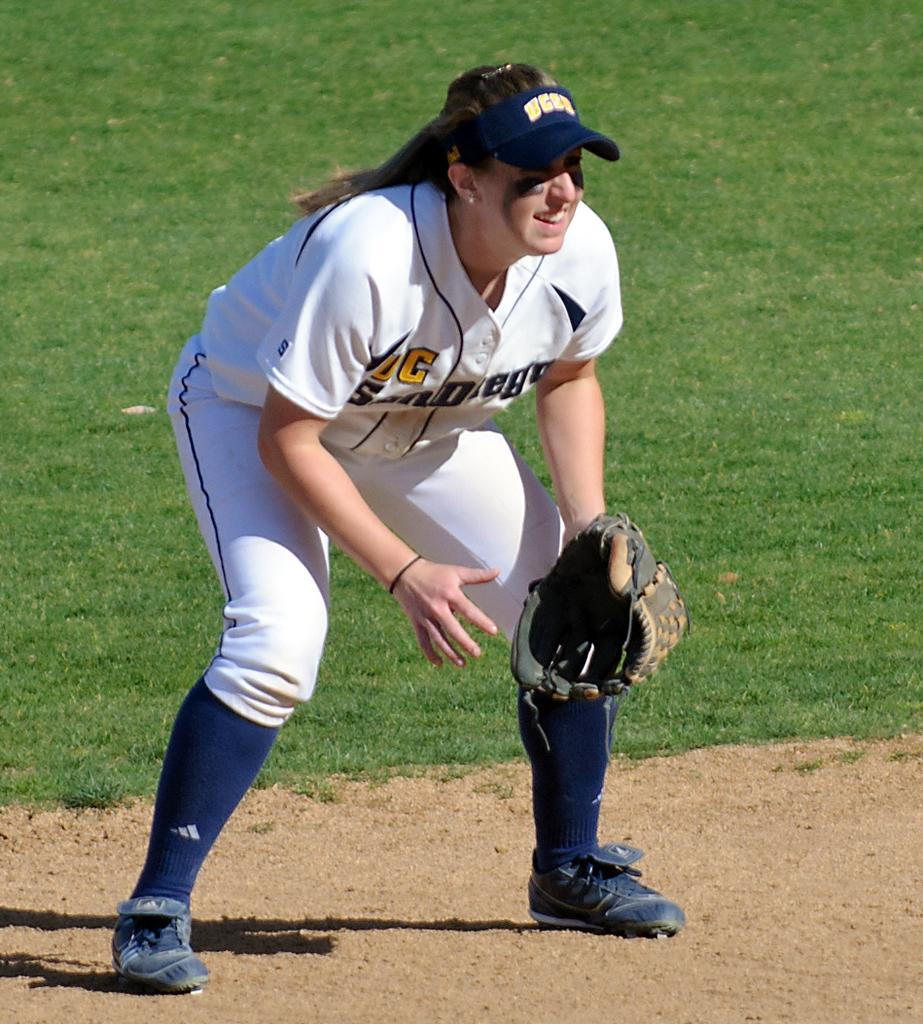<image>
Write a terse but informative summary of the picture. A woman wearing a softball uniform has a small "s" sewn onto her sleeve. 